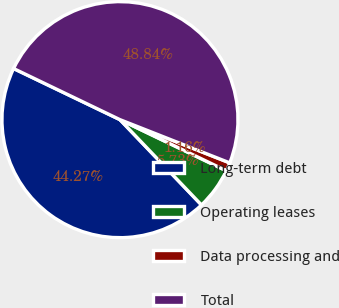<chart> <loc_0><loc_0><loc_500><loc_500><pie_chart><fcel>Long-term debt<fcel>Operating leases<fcel>Data processing and<fcel>Total<nl><fcel>44.27%<fcel>5.73%<fcel>1.16%<fcel>48.84%<nl></chart> 